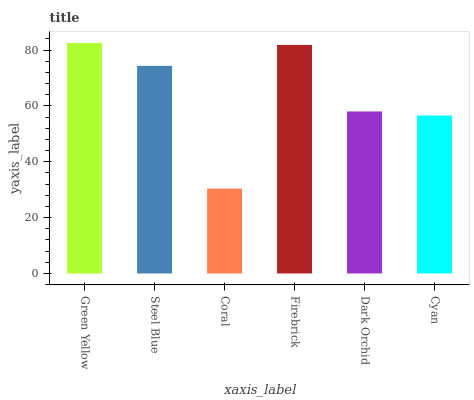Is Coral the minimum?
Answer yes or no. Yes. Is Green Yellow the maximum?
Answer yes or no. Yes. Is Steel Blue the minimum?
Answer yes or no. No. Is Steel Blue the maximum?
Answer yes or no. No. Is Green Yellow greater than Steel Blue?
Answer yes or no. Yes. Is Steel Blue less than Green Yellow?
Answer yes or no. Yes. Is Steel Blue greater than Green Yellow?
Answer yes or no. No. Is Green Yellow less than Steel Blue?
Answer yes or no. No. Is Steel Blue the high median?
Answer yes or no. Yes. Is Dark Orchid the low median?
Answer yes or no. Yes. Is Dark Orchid the high median?
Answer yes or no. No. Is Firebrick the low median?
Answer yes or no. No. 